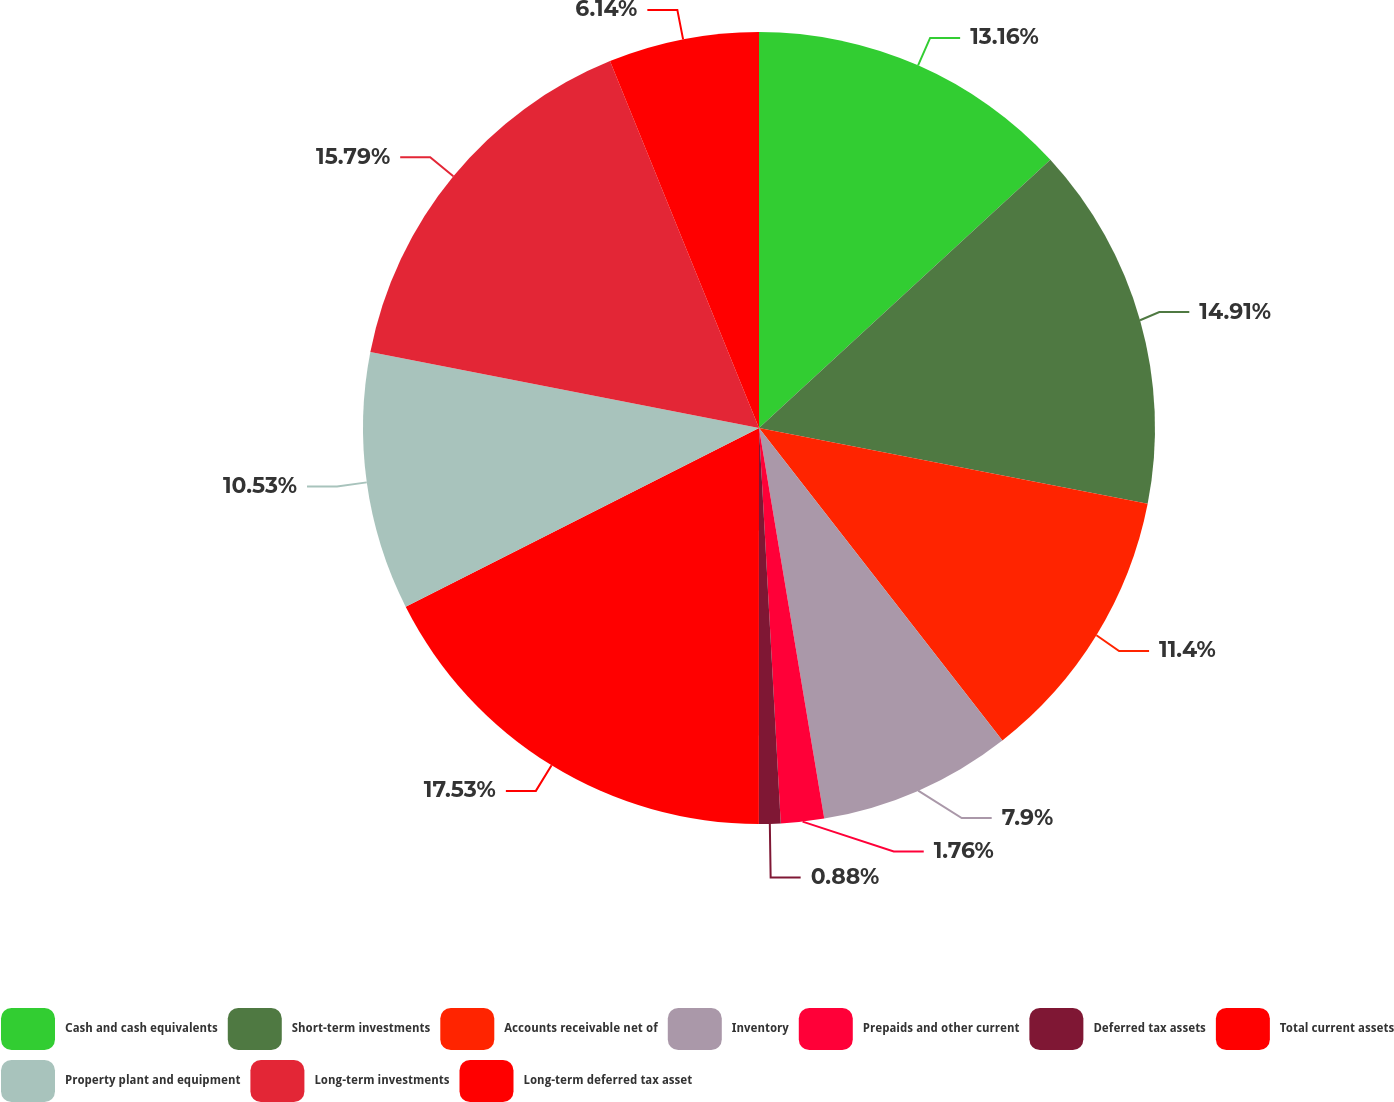<chart> <loc_0><loc_0><loc_500><loc_500><pie_chart><fcel>Cash and cash equivalents<fcel>Short-term investments<fcel>Accounts receivable net of<fcel>Inventory<fcel>Prepaids and other current<fcel>Deferred tax assets<fcel>Total current assets<fcel>Property plant and equipment<fcel>Long-term investments<fcel>Long-term deferred tax asset<nl><fcel>13.16%<fcel>14.91%<fcel>11.4%<fcel>7.9%<fcel>1.76%<fcel>0.88%<fcel>17.54%<fcel>10.53%<fcel>15.79%<fcel>6.14%<nl></chart> 